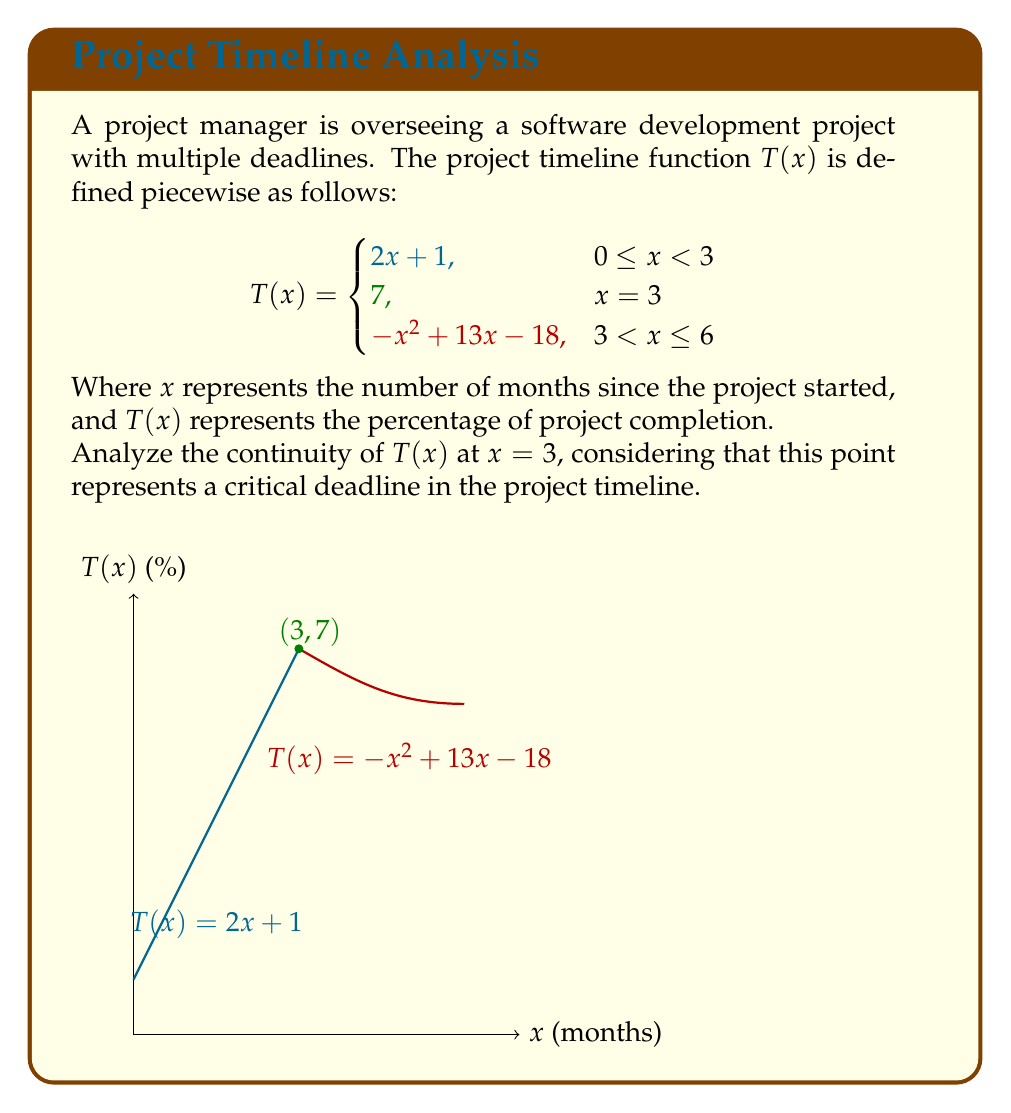Teach me how to tackle this problem. To analyze the continuity of $T(x)$ at $x = 3$, we need to check three conditions:

1. $T(3)$ exists
2. $\lim_{x \to 3^-} T(x)$ exists
3. $\lim_{x \to 3^+} T(x)$ exists
4. All three values are equal

Step 1: Check if $T(3)$ exists
$T(3) = 7$ (given in the piecewise function)

Step 2: Calculate $\lim_{x \to 3^-} T(x)$
For $x < 3$, we use $T(x) = 2x + 1$
$\lim_{x \to 3^-} T(x) = \lim_{x \to 3^-} (2x + 1) = 2(3) + 1 = 7$

Step 3: Calculate $\lim_{x \to 3^+} T(x)$
For $x > 3$, we use $T(x) = -x^2 + 13x - 18$
$\lim_{x \to 3^+} T(x) = \lim_{x \to 3^+} (-x^2 + 13x - 18) = -(3)^2 + 13(3) - 18 = 7$

Step 4: Compare the values
$T(3) = 7$
$\lim_{x \to 3^-} T(x) = 7$
$\lim_{x \to 3^+} T(x) = 7$

All three values are equal to 7, satisfying all conditions for continuity.
Answer: $T(x)$ is continuous at $x = 3$ 